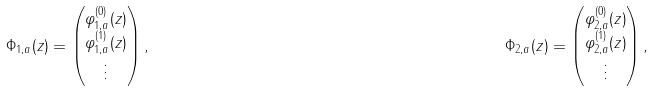Convert formula to latex. <formula><loc_0><loc_0><loc_500><loc_500>\Phi _ { 1 , a } ( z ) & = \begin{pmatrix} \varphi _ { 1 , a } ^ { ( 0 ) } ( z ) \\ \varphi _ { 1 , a } ^ { ( 1 ) } ( z ) \\ \vdots \end{pmatrix} , & \Phi _ { 2 , a } ( z ) & = \begin{pmatrix} \varphi _ { 2 , a } ^ { ( 0 ) } ( z ) \\ \varphi _ { 2 , a } ^ { ( 1 ) } ( z ) \\ \vdots \end{pmatrix} ,</formula> 